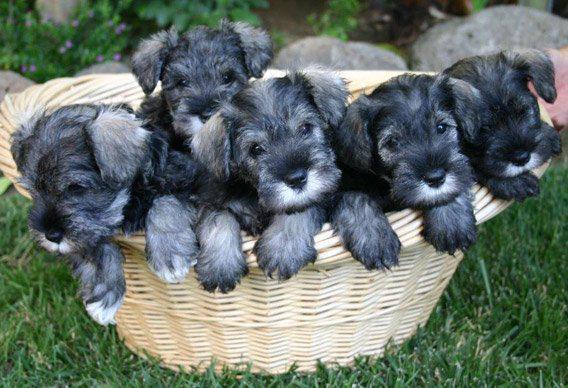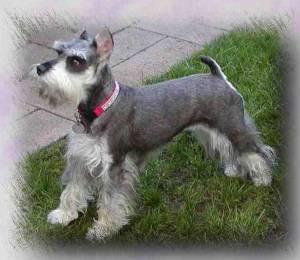The first image is the image on the left, the second image is the image on the right. Examine the images to the left and right. Is the description "In one image, a dog standing with legs straight and tail curled up is wearing a red collar." accurate? Answer yes or no. Yes. The first image is the image on the left, the second image is the image on the right. Analyze the images presented: Is the assertion "Right image shows a schnauzer in a collar standing facing leftward." valid? Answer yes or no. Yes. 